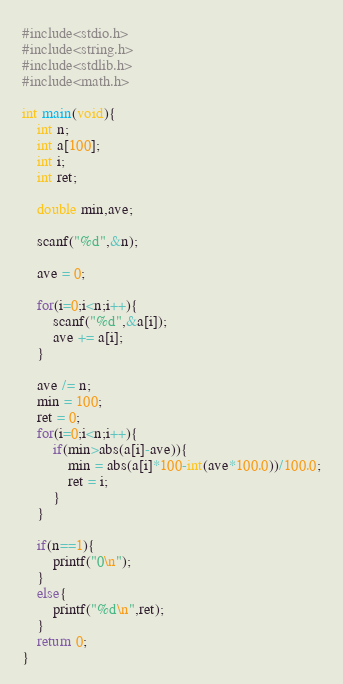Convert code to text. <code><loc_0><loc_0><loc_500><loc_500><_C++_>#include<stdio.h>
#include<string.h> 
#include<stdlib.h>
#include<math.h>

int main(void){
	int n;
	int a[100];	
	int i;
	int ret;

	double min,ave;

	scanf("%d",&n);

	ave = 0;

	for(i=0;i<n;i++){
		scanf("%d",&a[i]);
		ave += a[i];
	}

	ave /= n;
	min = 100;
	ret = 0;
	for(i=0;i<n;i++){
		if(min>abs(a[i]-ave)){
			min = abs(a[i]*100-int(ave*100.0))/100.0;
			ret = i;
		}
	}

	if(n==1){
		printf("0\n");
	}
	else{
		printf("%d\n",ret);
	}
	return 0;
}
</code> 